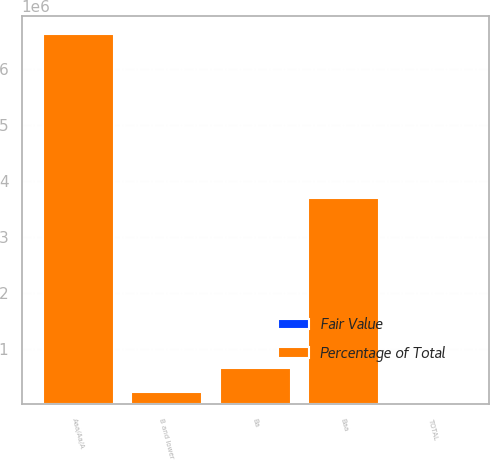<chart> <loc_0><loc_0><loc_500><loc_500><stacked_bar_chart><ecel><fcel>Aaa/Aa/A<fcel>Baa<fcel>Ba<fcel>B and lower<fcel>TOTAL<nl><fcel>Percentage of Total<fcel>6.62081e+06<fcel>3.69271e+06<fcel>648817<fcel>230265<fcel>100<nl><fcel>Fair Value<fcel>59<fcel>33<fcel>6<fcel>2<fcel>100<nl></chart> 